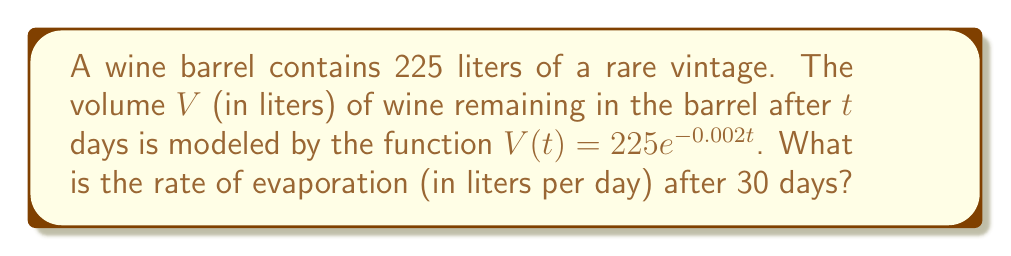Help me with this question. To find the rate of evaporation after 30 days, we need to calculate the derivative of the volume function $V(t)$ and evaluate it at $t=30$. The steps are as follows:

1) The given function is $V(t) = 225e^{-0.002t}$

2) To find the rate of change (evaporation rate), we need to differentiate $V(t)$ with respect to $t$:

   $$\frac{dV}{dt} = 225 \cdot (-0.002) \cdot e^{-0.002t}$$
   
   $$\frac{dV}{dt} = -0.45e^{-0.002t}$$

3) The negative sign indicates that the volume is decreasing (evaporating).

4) To find the rate after 30 days, we evaluate $\frac{dV}{dt}$ at $t=30$:

   $$\frac{dV}{dt}(30) = -0.45e^{-0.002(30)}$$
   
   $$= -0.45e^{-0.06}$$
   
   $$\approx -0.4233$$

5) The absolute value of this result gives us the evaporation rate.

Therefore, the rate of evaporation after 30 days is approximately 0.4233 liters per day.
Answer: 0.4233 liters/day 